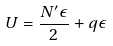<formula> <loc_0><loc_0><loc_500><loc_500>U = \frac { N ^ { \prime } \epsilon } { 2 } + q \epsilon</formula> 